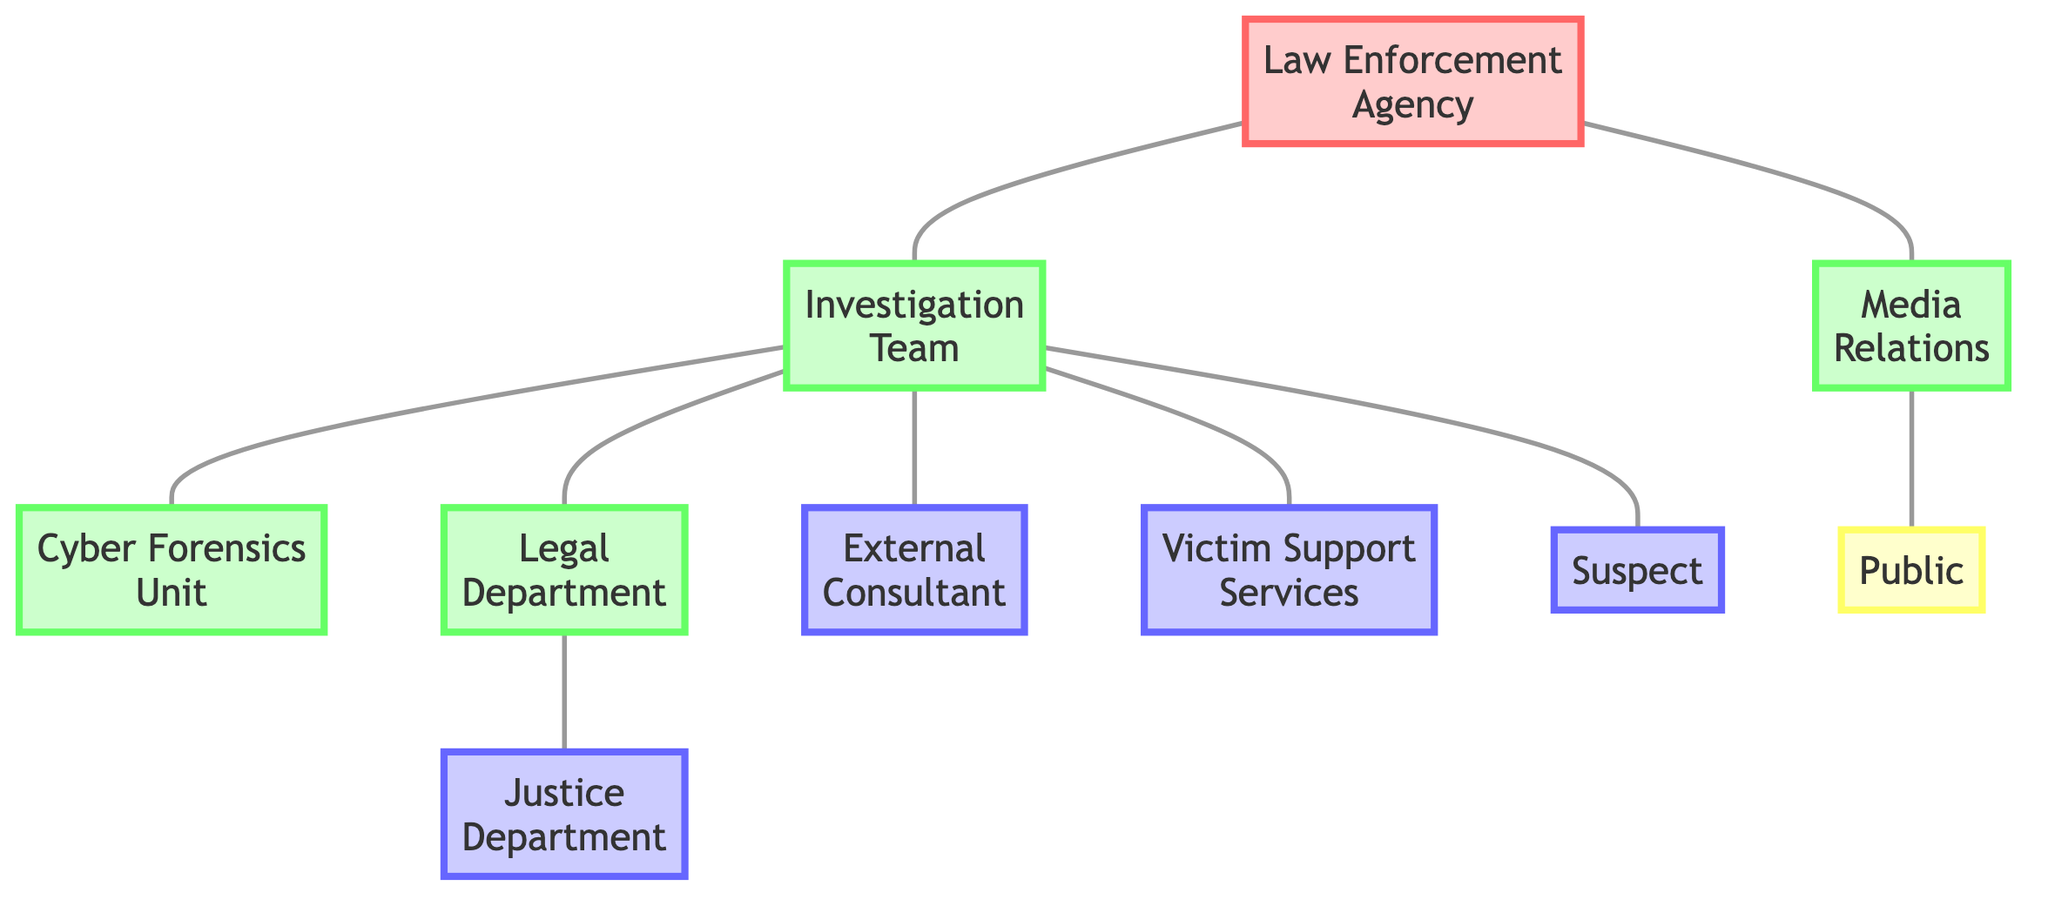What is the total number of nodes in the diagram? The diagram consists of 10 distinct nodes including the law enforcement agency, investigation team, cyber forensics unit, legal department, external consultant, justice department, victim support services, media relations, public, and suspect. By counting each of these unique entities, the total number of nodes is determined to be 10.
Answer: 10 Which departments does the investigation team communicate with? The diagram shows that the investigation team directly communicates with the cyber forensics unit, legal department, external consultant, victim support services, and the suspect. This can be observed from the edges directly connecting these nodes to the investigation team.
Answer: Cyber Forensics Unit, Legal Department, External Consultant, Victim Support Services, Suspect How many connections does the law enforcement agency have? In the diagram, the law enforcement agency has connections to the investigation team and media relations. This means the law enforcement agency is linked to 2 different entities. By counting the edges emanating from the law enforcement agency node, we find its connection count.
Answer: 2 What is the path of communication from the legal department to the public? The communication path from the legal department to the public is facilitated through the justice department and media relations. It goes from the legal department to the justice department, then to media relations, and finally to the public. This sequence shows the flow of information from one node to the other.
Answer: Legal Department → Justice Department → Media Relations → Public Which team directly interacts with the suspect? The diagram indicates that the investigation team directly interacts with the suspect. This is visible by their direct connection (edge) in the graph, showing a direct line of communication between these two nodes.
Answer: Investigation Team How many external stakeholders are mentioned in the diagram? The diagram identifies 4 external stakeholders: the external consultant, justice department, victim support services, and the suspect. By counting the number of unique nodes categorized as external, the total is determined.
Answer: 4 Which department relies on cyber forensics unit for support? The investigation team relies on the cyber forensics unit for support. This is indicated by the direct edge connecting the investigation team to the cyber forensics unit, showing that one department depends on the other for its operations.
Answer: Investigation Team What are the primary roles of media relations in the flow of information? Media relations primarily facilitate communication between the law enforcement agency and the public. From the diagram, the media relations node connects directly to both the law enforcement agency and the public, showing that it serves as a bridge in this flow of information.
Answer: Communication bridge Which department is linked to the justice department? The legal department is directly linked to the justice department. This connection is evident from the diagram, where an edge exists that demonstrates the relationship between these two entities.
Answer: Legal Department 